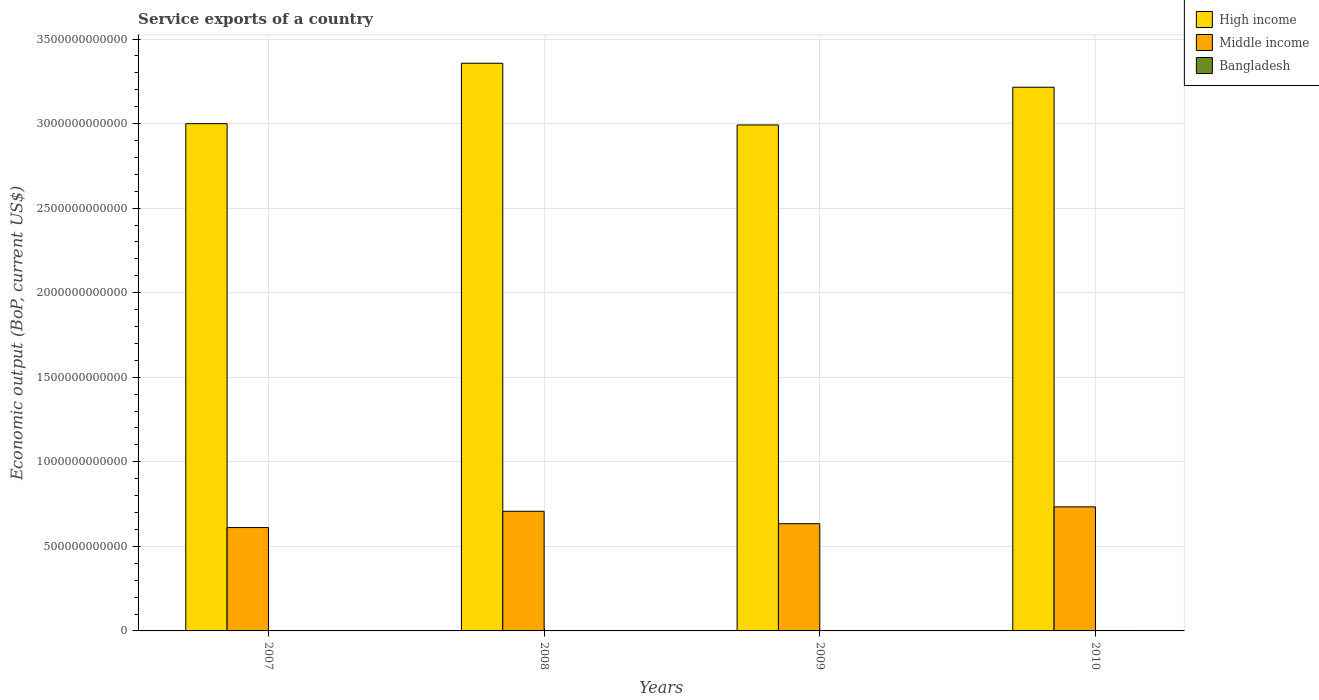How many groups of bars are there?
Offer a very short reply. 4. How many bars are there on the 3rd tick from the left?
Offer a very short reply. 3. How many bars are there on the 2nd tick from the right?
Offer a terse response. 3. What is the service exports in Bangladesh in 2009?
Offer a very short reply. 2.10e+09. Across all years, what is the maximum service exports in Middle income?
Make the answer very short. 7.34e+11. Across all years, what is the minimum service exports in High income?
Provide a short and direct response. 2.99e+12. What is the total service exports in Bangladesh in the graph?
Keep it short and to the point. 8.50e+09. What is the difference between the service exports in High income in 2007 and that in 2009?
Offer a very short reply. 7.66e+09. What is the difference between the service exports in Bangladesh in 2010 and the service exports in Middle income in 2009?
Provide a short and direct response. -6.31e+11. What is the average service exports in Bangladesh per year?
Provide a short and direct response. 2.12e+09. In the year 2009, what is the difference between the service exports in Middle income and service exports in High income?
Give a very brief answer. -2.36e+12. What is the ratio of the service exports in Bangladesh in 2009 to that in 2010?
Your answer should be very brief. 0.82. What is the difference between the highest and the second highest service exports in Middle income?
Make the answer very short. 2.62e+1. What is the difference between the highest and the lowest service exports in Middle income?
Offer a terse response. 1.23e+11. In how many years, is the service exports in Middle income greater than the average service exports in Middle income taken over all years?
Provide a succinct answer. 2. Is the sum of the service exports in High income in 2008 and 2010 greater than the maximum service exports in Middle income across all years?
Offer a very short reply. Yes. Is it the case that in every year, the sum of the service exports in Bangladesh and service exports in Middle income is greater than the service exports in High income?
Your response must be concise. No. How many years are there in the graph?
Keep it short and to the point. 4. What is the difference between two consecutive major ticks on the Y-axis?
Your response must be concise. 5.00e+11. Does the graph contain any zero values?
Keep it short and to the point. No. How are the legend labels stacked?
Ensure brevity in your answer.  Vertical. What is the title of the graph?
Ensure brevity in your answer.  Service exports of a country. What is the label or title of the Y-axis?
Offer a terse response. Economic output (BoP, current US$). What is the Economic output (BoP, current US$) of High income in 2007?
Make the answer very short. 3.00e+12. What is the Economic output (BoP, current US$) in Middle income in 2007?
Give a very brief answer. 6.11e+11. What is the Economic output (BoP, current US$) in Bangladesh in 2007?
Provide a short and direct response. 1.90e+09. What is the Economic output (BoP, current US$) in High income in 2008?
Your answer should be very brief. 3.36e+12. What is the Economic output (BoP, current US$) in Middle income in 2008?
Ensure brevity in your answer.  7.08e+11. What is the Economic output (BoP, current US$) of Bangladesh in 2008?
Your answer should be very brief. 1.94e+09. What is the Economic output (BoP, current US$) of High income in 2009?
Make the answer very short. 2.99e+12. What is the Economic output (BoP, current US$) in Middle income in 2009?
Make the answer very short. 6.34e+11. What is the Economic output (BoP, current US$) of Bangladesh in 2009?
Your answer should be compact. 2.10e+09. What is the Economic output (BoP, current US$) in High income in 2010?
Your answer should be compact. 3.22e+12. What is the Economic output (BoP, current US$) of Middle income in 2010?
Ensure brevity in your answer.  7.34e+11. What is the Economic output (BoP, current US$) in Bangladesh in 2010?
Provide a short and direct response. 2.55e+09. Across all years, what is the maximum Economic output (BoP, current US$) of High income?
Give a very brief answer. 3.36e+12. Across all years, what is the maximum Economic output (BoP, current US$) in Middle income?
Keep it short and to the point. 7.34e+11. Across all years, what is the maximum Economic output (BoP, current US$) in Bangladesh?
Provide a short and direct response. 2.55e+09. Across all years, what is the minimum Economic output (BoP, current US$) of High income?
Provide a short and direct response. 2.99e+12. Across all years, what is the minimum Economic output (BoP, current US$) of Middle income?
Offer a terse response. 6.11e+11. Across all years, what is the minimum Economic output (BoP, current US$) of Bangladesh?
Offer a terse response. 1.90e+09. What is the total Economic output (BoP, current US$) in High income in the graph?
Keep it short and to the point. 1.26e+13. What is the total Economic output (BoP, current US$) of Middle income in the graph?
Offer a terse response. 2.69e+12. What is the total Economic output (BoP, current US$) in Bangladesh in the graph?
Offer a terse response. 8.50e+09. What is the difference between the Economic output (BoP, current US$) in High income in 2007 and that in 2008?
Provide a succinct answer. -3.57e+11. What is the difference between the Economic output (BoP, current US$) of Middle income in 2007 and that in 2008?
Give a very brief answer. -9.64e+1. What is the difference between the Economic output (BoP, current US$) of Bangladesh in 2007 and that in 2008?
Your answer should be very brief. -4.64e+07. What is the difference between the Economic output (BoP, current US$) of High income in 2007 and that in 2009?
Offer a terse response. 7.66e+09. What is the difference between the Economic output (BoP, current US$) in Middle income in 2007 and that in 2009?
Make the answer very short. -2.28e+1. What is the difference between the Economic output (BoP, current US$) of Bangladesh in 2007 and that in 2009?
Ensure brevity in your answer.  -2.07e+08. What is the difference between the Economic output (BoP, current US$) in High income in 2007 and that in 2010?
Provide a short and direct response. -2.15e+11. What is the difference between the Economic output (BoP, current US$) in Middle income in 2007 and that in 2010?
Your response must be concise. -1.23e+11. What is the difference between the Economic output (BoP, current US$) in Bangladesh in 2007 and that in 2010?
Your response must be concise. -6.54e+08. What is the difference between the Economic output (BoP, current US$) of High income in 2008 and that in 2009?
Provide a succinct answer. 3.65e+11. What is the difference between the Economic output (BoP, current US$) of Middle income in 2008 and that in 2009?
Offer a very short reply. 7.36e+1. What is the difference between the Economic output (BoP, current US$) of Bangladesh in 2008 and that in 2009?
Your response must be concise. -1.61e+08. What is the difference between the Economic output (BoP, current US$) of High income in 2008 and that in 2010?
Keep it short and to the point. 1.42e+11. What is the difference between the Economic output (BoP, current US$) in Middle income in 2008 and that in 2010?
Make the answer very short. -2.62e+1. What is the difference between the Economic output (BoP, current US$) in Bangladesh in 2008 and that in 2010?
Your answer should be very brief. -6.08e+08. What is the difference between the Economic output (BoP, current US$) of High income in 2009 and that in 2010?
Your answer should be very brief. -2.23e+11. What is the difference between the Economic output (BoP, current US$) of Middle income in 2009 and that in 2010?
Ensure brevity in your answer.  -9.98e+1. What is the difference between the Economic output (BoP, current US$) in Bangladesh in 2009 and that in 2010?
Your answer should be compact. -4.47e+08. What is the difference between the Economic output (BoP, current US$) of High income in 2007 and the Economic output (BoP, current US$) of Middle income in 2008?
Give a very brief answer. 2.29e+12. What is the difference between the Economic output (BoP, current US$) in High income in 2007 and the Economic output (BoP, current US$) in Bangladesh in 2008?
Provide a succinct answer. 3.00e+12. What is the difference between the Economic output (BoP, current US$) in Middle income in 2007 and the Economic output (BoP, current US$) in Bangladesh in 2008?
Keep it short and to the point. 6.09e+11. What is the difference between the Economic output (BoP, current US$) of High income in 2007 and the Economic output (BoP, current US$) of Middle income in 2009?
Your answer should be very brief. 2.37e+12. What is the difference between the Economic output (BoP, current US$) of High income in 2007 and the Economic output (BoP, current US$) of Bangladesh in 2009?
Make the answer very short. 3.00e+12. What is the difference between the Economic output (BoP, current US$) of Middle income in 2007 and the Economic output (BoP, current US$) of Bangladesh in 2009?
Provide a succinct answer. 6.09e+11. What is the difference between the Economic output (BoP, current US$) of High income in 2007 and the Economic output (BoP, current US$) of Middle income in 2010?
Offer a very short reply. 2.27e+12. What is the difference between the Economic output (BoP, current US$) of High income in 2007 and the Economic output (BoP, current US$) of Bangladesh in 2010?
Make the answer very short. 3.00e+12. What is the difference between the Economic output (BoP, current US$) in Middle income in 2007 and the Economic output (BoP, current US$) in Bangladesh in 2010?
Your answer should be compact. 6.09e+11. What is the difference between the Economic output (BoP, current US$) of High income in 2008 and the Economic output (BoP, current US$) of Middle income in 2009?
Your answer should be compact. 2.72e+12. What is the difference between the Economic output (BoP, current US$) of High income in 2008 and the Economic output (BoP, current US$) of Bangladesh in 2009?
Give a very brief answer. 3.35e+12. What is the difference between the Economic output (BoP, current US$) in Middle income in 2008 and the Economic output (BoP, current US$) in Bangladesh in 2009?
Ensure brevity in your answer.  7.05e+11. What is the difference between the Economic output (BoP, current US$) of High income in 2008 and the Economic output (BoP, current US$) of Middle income in 2010?
Offer a terse response. 2.62e+12. What is the difference between the Economic output (BoP, current US$) in High income in 2008 and the Economic output (BoP, current US$) in Bangladesh in 2010?
Your answer should be compact. 3.35e+12. What is the difference between the Economic output (BoP, current US$) of Middle income in 2008 and the Economic output (BoP, current US$) of Bangladesh in 2010?
Provide a succinct answer. 7.05e+11. What is the difference between the Economic output (BoP, current US$) in High income in 2009 and the Economic output (BoP, current US$) in Middle income in 2010?
Keep it short and to the point. 2.26e+12. What is the difference between the Economic output (BoP, current US$) of High income in 2009 and the Economic output (BoP, current US$) of Bangladesh in 2010?
Your response must be concise. 2.99e+12. What is the difference between the Economic output (BoP, current US$) of Middle income in 2009 and the Economic output (BoP, current US$) of Bangladesh in 2010?
Give a very brief answer. 6.31e+11. What is the average Economic output (BoP, current US$) in High income per year?
Offer a very short reply. 3.14e+12. What is the average Economic output (BoP, current US$) of Middle income per year?
Offer a very short reply. 6.72e+11. What is the average Economic output (BoP, current US$) of Bangladesh per year?
Your answer should be compact. 2.12e+09. In the year 2007, what is the difference between the Economic output (BoP, current US$) in High income and Economic output (BoP, current US$) in Middle income?
Ensure brevity in your answer.  2.39e+12. In the year 2007, what is the difference between the Economic output (BoP, current US$) of High income and Economic output (BoP, current US$) of Bangladesh?
Provide a short and direct response. 3.00e+12. In the year 2007, what is the difference between the Economic output (BoP, current US$) of Middle income and Economic output (BoP, current US$) of Bangladesh?
Provide a succinct answer. 6.09e+11. In the year 2008, what is the difference between the Economic output (BoP, current US$) of High income and Economic output (BoP, current US$) of Middle income?
Give a very brief answer. 2.65e+12. In the year 2008, what is the difference between the Economic output (BoP, current US$) in High income and Economic output (BoP, current US$) in Bangladesh?
Give a very brief answer. 3.35e+12. In the year 2008, what is the difference between the Economic output (BoP, current US$) of Middle income and Economic output (BoP, current US$) of Bangladesh?
Give a very brief answer. 7.06e+11. In the year 2009, what is the difference between the Economic output (BoP, current US$) of High income and Economic output (BoP, current US$) of Middle income?
Provide a succinct answer. 2.36e+12. In the year 2009, what is the difference between the Economic output (BoP, current US$) in High income and Economic output (BoP, current US$) in Bangladesh?
Provide a short and direct response. 2.99e+12. In the year 2009, what is the difference between the Economic output (BoP, current US$) in Middle income and Economic output (BoP, current US$) in Bangladesh?
Your answer should be very brief. 6.32e+11. In the year 2010, what is the difference between the Economic output (BoP, current US$) of High income and Economic output (BoP, current US$) of Middle income?
Your response must be concise. 2.48e+12. In the year 2010, what is the difference between the Economic output (BoP, current US$) of High income and Economic output (BoP, current US$) of Bangladesh?
Provide a succinct answer. 3.21e+12. In the year 2010, what is the difference between the Economic output (BoP, current US$) of Middle income and Economic output (BoP, current US$) of Bangladesh?
Make the answer very short. 7.31e+11. What is the ratio of the Economic output (BoP, current US$) in High income in 2007 to that in 2008?
Your response must be concise. 0.89. What is the ratio of the Economic output (BoP, current US$) of Middle income in 2007 to that in 2008?
Give a very brief answer. 0.86. What is the ratio of the Economic output (BoP, current US$) of Bangladesh in 2007 to that in 2008?
Your answer should be compact. 0.98. What is the ratio of the Economic output (BoP, current US$) of High income in 2007 to that in 2009?
Your answer should be compact. 1. What is the ratio of the Economic output (BoP, current US$) in Middle income in 2007 to that in 2009?
Provide a succinct answer. 0.96. What is the ratio of the Economic output (BoP, current US$) in Bangladesh in 2007 to that in 2009?
Your answer should be compact. 0.9. What is the ratio of the Economic output (BoP, current US$) of High income in 2007 to that in 2010?
Your answer should be compact. 0.93. What is the ratio of the Economic output (BoP, current US$) of Middle income in 2007 to that in 2010?
Your answer should be compact. 0.83. What is the ratio of the Economic output (BoP, current US$) of Bangladesh in 2007 to that in 2010?
Ensure brevity in your answer.  0.74. What is the ratio of the Economic output (BoP, current US$) of High income in 2008 to that in 2009?
Your answer should be compact. 1.12. What is the ratio of the Economic output (BoP, current US$) in Middle income in 2008 to that in 2009?
Give a very brief answer. 1.12. What is the ratio of the Economic output (BoP, current US$) in Bangladesh in 2008 to that in 2009?
Provide a short and direct response. 0.92. What is the ratio of the Economic output (BoP, current US$) in High income in 2008 to that in 2010?
Give a very brief answer. 1.04. What is the ratio of the Economic output (BoP, current US$) in Middle income in 2008 to that in 2010?
Your answer should be very brief. 0.96. What is the ratio of the Economic output (BoP, current US$) in Bangladesh in 2008 to that in 2010?
Offer a very short reply. 0.76. What is the ratio of the Economic output (BoP, current US$) of High income in 2009 to that in 2010?
Keep it short and to the point. 0.93. What is the ratio of the Economic output (BoP, current US$) of Middle income in 2009 to that in 2010?
Ensure brevity in your answer.  0.86. What is the ratio of the Economic output (BoP, current US$) of Bangladesh in 2009 to that in 2010?
Provide a succinct answer. 0.82. What is the difference between the highest and the second highest Economic output (BoP, current US$) of High income?
Offer a terse response. 1.42e+11. What is the difference between the highest and the second highest Economic output (BoP, current US$) of Middle income?
Give a very brief answer. 2.62e+1. What is the difference between the highest and the second highest Economic output (BoP, current US$) in Bangladesh?
Give a very brief answer. 4.47e+08. What is the difference between the highest and the lowest Economic output (BoP, current US$) of High income?
Offer a terse response. 3.65e+11. What is the difference between the highest and the lowest Economic output (BoP, current US$) of Middle income?
Ensure brevity in your answer.  1.23e+11. What is the difference between the highest and the lowest Economic output (BoP, current US$) in Bangladesh?
Keep it short and to the point. 6.54e+08. 